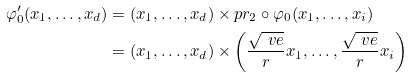Convert formula to latex. <formula><loc_0><loc_0><loc_500><loc_500>\varphi _ { 0 } ^ { \prime } ( x _ { 1 } , \dots , x _ { d } ) & = ( x _ { 1 } , \dots , x _ { d } ) \times p r _ { 2 } \circ \varphi _ { 0 } ( x _ { 1 } , \dots , x _ { i } ) \\ & = ( x _ { 1 } , \dots , x _ { d } ) \times \left ( \frac { \sqrt { \ v e } } { r } x _ { 1 } , \dots , \frac { \sqrt { \ v e } } { r } x _ { i } \right )</formula> 